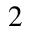<formula> <loc_0><loc_0><loc_500><loc_500>2</formula> 